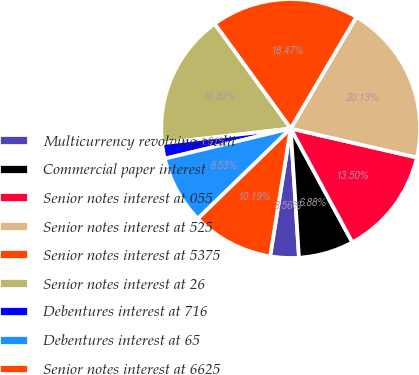Convert chart. <chart><loc_0><loc_0><loc_500><loc_500><pie_chart><fcel>Multicurrency revolving credit<fcel>Commercial paper interest<fcel>Senior notes interest at 055<fcel>Senior notes interest at 525<fcel>Senior notes interest at 5375<fcel>Senior notes interest at 26<fcel>Debentures interest at 716<fcel>Debentures interest at 65<fcel>Senior notes interest at 6625<nl><fcel>3.56%<fcel>6.88%<fcel>13.5%<fcel>20.13%<fcel>18.47%<fcel>16.82%<fcel>1.91%<fcel>8.53%<fcel>10.19%<nl></chart> 